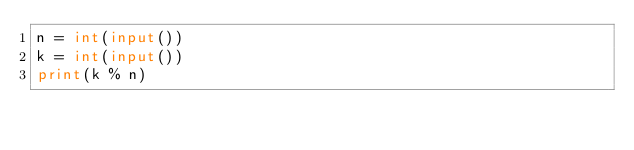<code> <loc_0><loc_0><loc_500><loc_500><_Python_>n = int(input())
k = int(input())
print(k % n)
</code> 